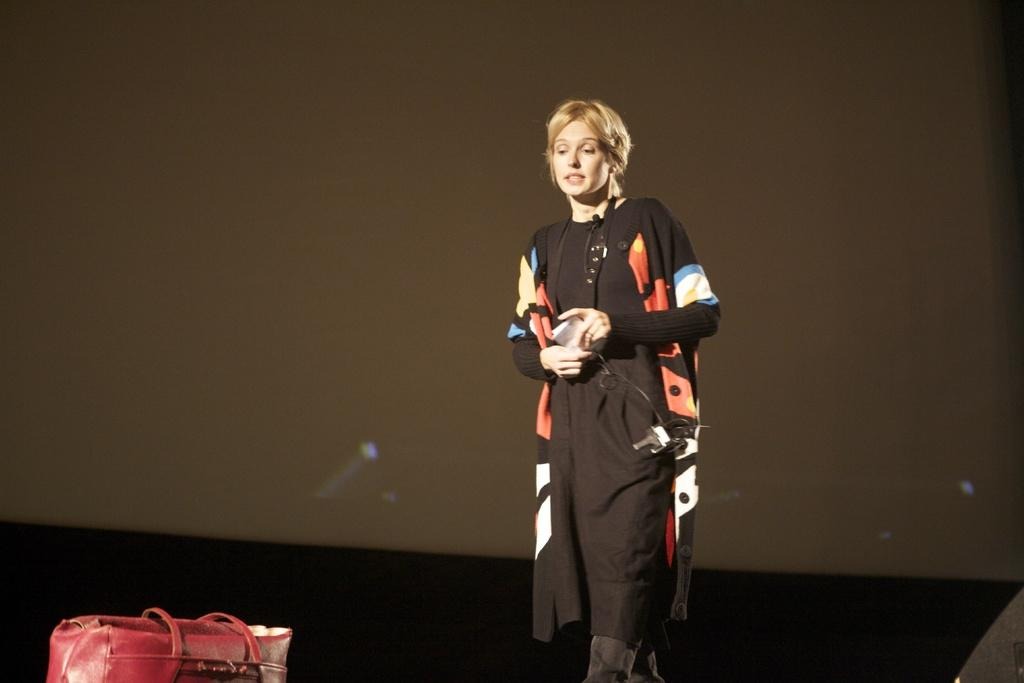Who is present in the image? There is a woman in the image. What is the woman holding? The woman is holding a paper. What is the woman's action in the image? The woman is walking towards a red color bag. What can be seen in the background of the image? There is a wall in the background of the image. How far is the market from the woman in the image? There is no information about a market in the image, so we cannot determine its distance from the woman. 